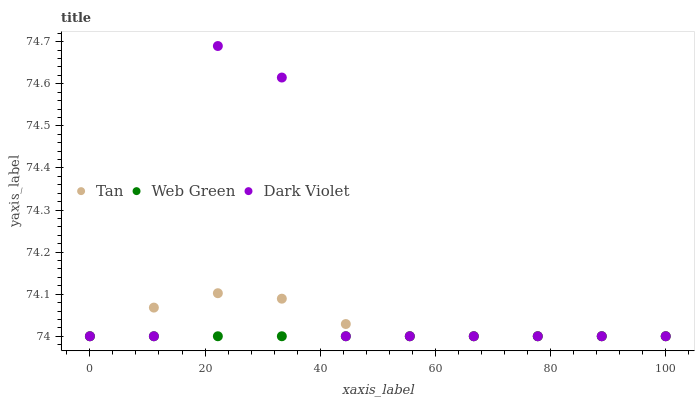Does Web Green have the minimum area under the curve?
Answer yes or no. Yes. Does Dark Violet have the maximum area under the curve?
Answer yes or no. Yes. Does Dark Violet have the minimum area under the curve?
Answer yes or no. No. Does Web Green have the maximum area under the curve?
Answer yes or no. No. Is Web Green the smoothest?
Answer yes or no. Yes. Is Dark Violet the roughest?
Answer yes or no. Yes. Is Dark Violet the smoothest?
Answer yes or no. No. Is Web Green the roughest?
Answer yes or no. No. Does Tan have the lowest value?
Answer yes or no. Yes. Does Dark Violet have the highest value?
Answer yes or no. Yes. Does Web Green have the highest value?
Answer yes or no. No. Does Tan intersect Dark Violet?
Answer yes or no. Yes. Is Tan less than Dark Violet?
Answer yes or no. No. Is Tan greater than Dark Violet?
Answer yes or no. No. 